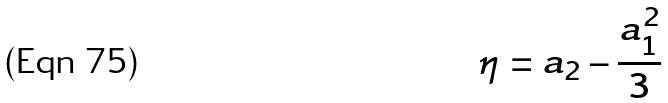<formula> <loc_0><loc_0><loc_500><loc_500>\eta = a _ { 2 } - \frac { a _ { 1 } ^ { 2 } } { 3 }</formula> 